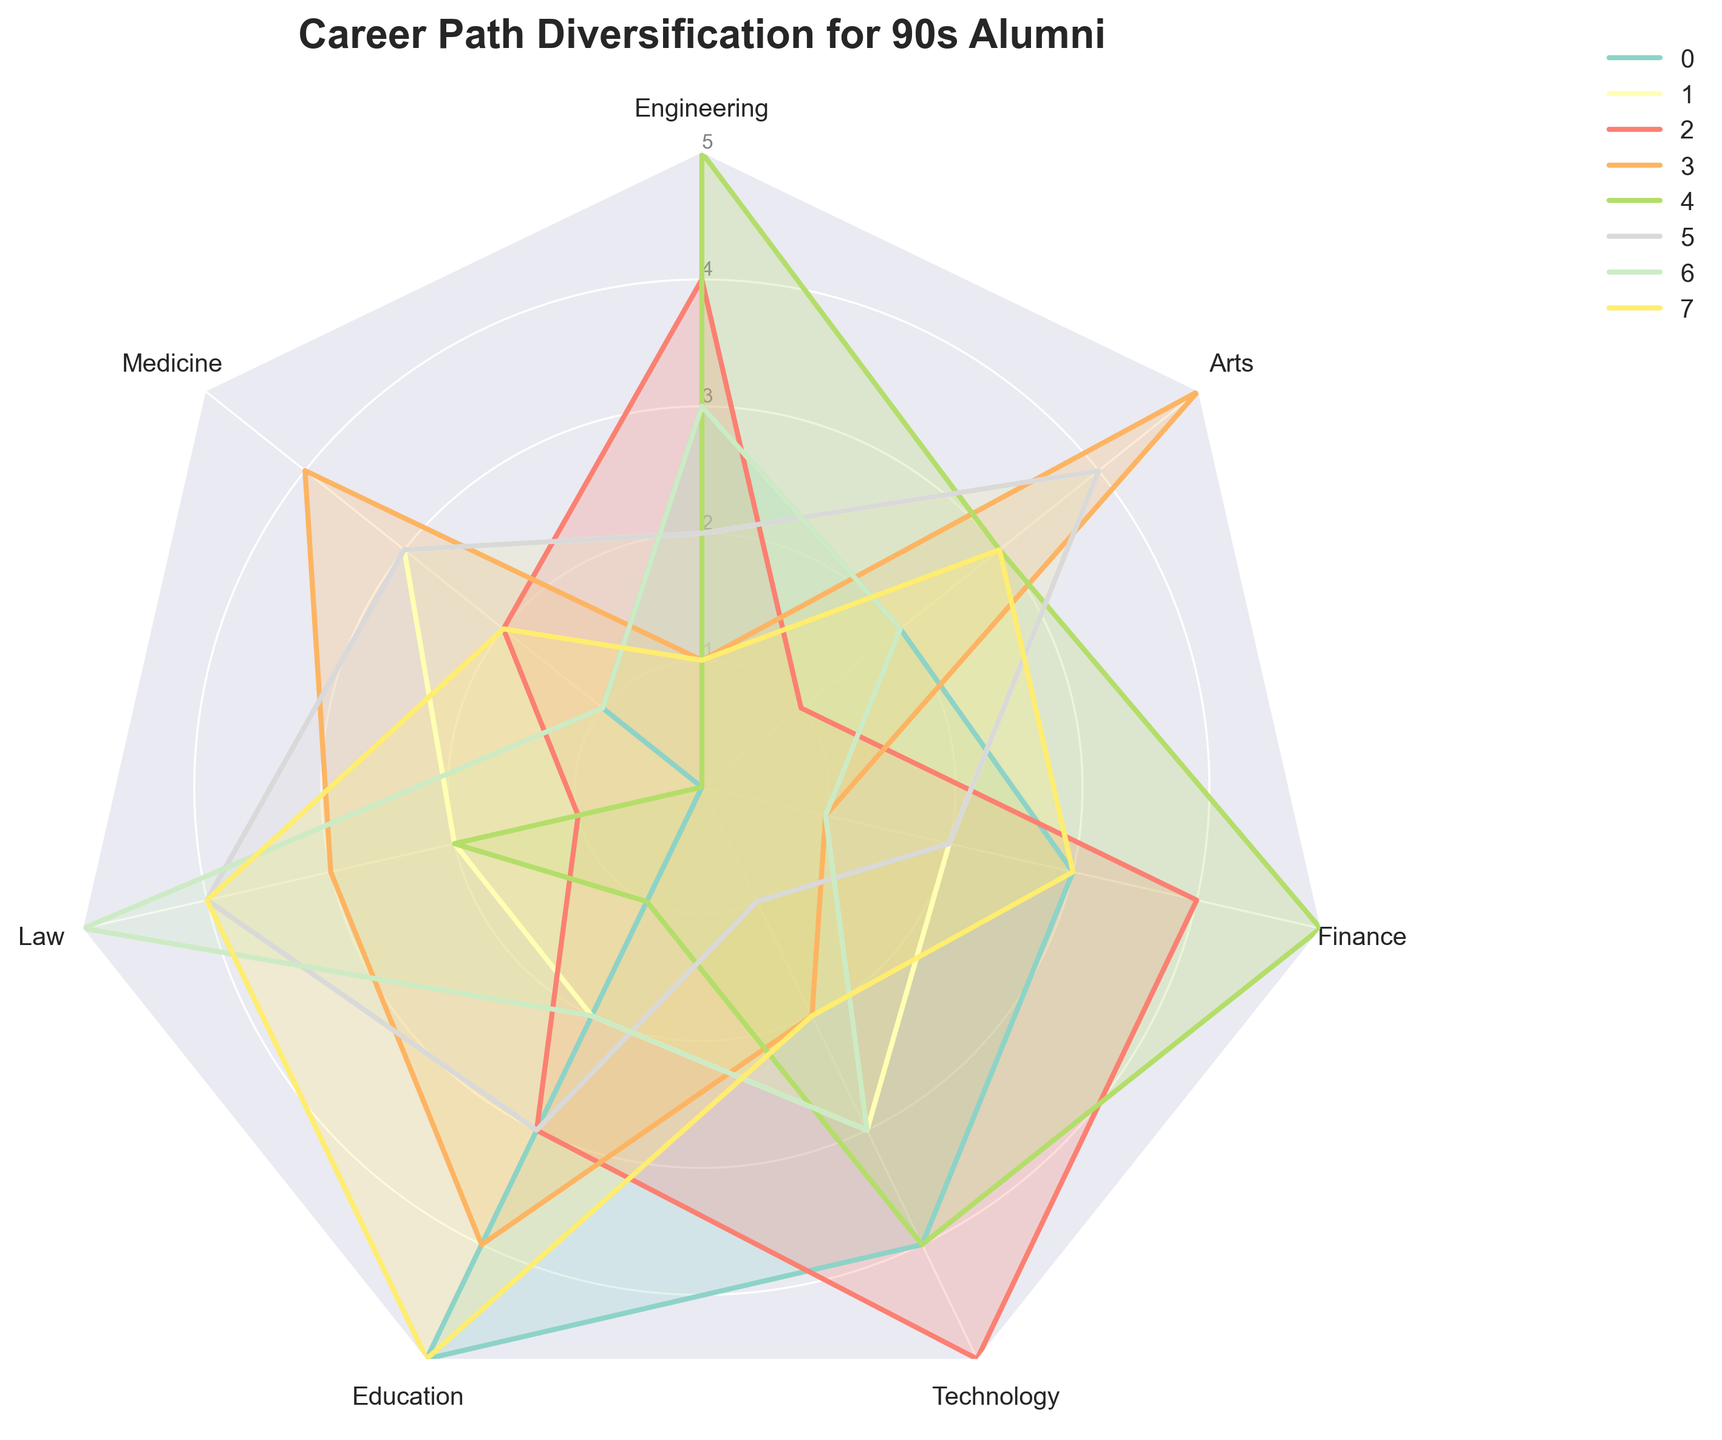What is the title of the radar chart? The title is typically located at the top of the chart. In this case, it reads "Career Path Diversification for 90s Alumni".
Answer: Career Path Diversification for 90s Alumni How many career categories are shown in the radar chart? To find the number of career categories, count the number of points on the radar chart. Here, the labels are Engineering, Medicine, Law, Education, Technology, Finance, and Arts.
Answer: 7 Which alumnus has the highest score in Engineering? By looking at the points in the Engineering category across all alumni, we see that Michael Brown has the highest score of 5.
Answer: Michael Brown What is the average score of Emily Davis across all categories? To find the average, add Emily Davis's scores in all categories: 1 (Engineering), 4 (Medicine), 3 (Law), 4 (Education), 2 (Technology), 1 (Finance), and 5 (Arts). Then divide by the number of categories: (1+4+3+4+2+1+5) / 7.
Answer: 2.86 Who scored the highest in the Arts category and what is their score? In the Arts category, the highest scores are noted. Both Emily Davis and Sarah Wilson scored 5.
Answer: Emily Davis and Sarah Wilson, 5 Which two alumni have the same scores in any category? John Smith and David Miller both scored 3 in Engineering.
Answer: John Smith and David Miller What is the median score in the Technology category across all alumni? First list all scores in Technology: 4, 3, 5, 2, 4, 1, 3, 2. Arrange them in ascending order: 1, 2, 2, 3, 3, 4, 4, 5. The median score is the average of the fourth and fifth values: (3+3)/2.
Answer: 3 Who has the lowest score in Medicine, and what is that score? By checking all scores in the Medicine category, Michael Brown has the lowest score, which is 0.
Answer: Michael Brown, 0 Compare the average scores of John Smith and Jane Doe. Who has a higher average score? Sum the scores of John Smith (3+1+0+5+4+3+2) and divide by 7 to get an average of 2.57. Sum the scores of Jane Doe (2+3+2+2+3+2+4) and divide by 7 to get an average of 2.57. Both have the same average score.
Answer: Tie Which alumnus has the most balanced career path diversification, meaning the smallest range between their highest and lowest scores? Calculate the range for each alumnus by subtracting the lowest score from the highest score in each category. John Smith has scores (3, 1, 0, 5, 4, 3, 2) with a range of 5-0=5. Continue for others and find that Jane Doe's scores (2, 3, 2, 2, 3, 2, 4) have the range 4-2=2, the smallest range.
Answer: Jane Doe 